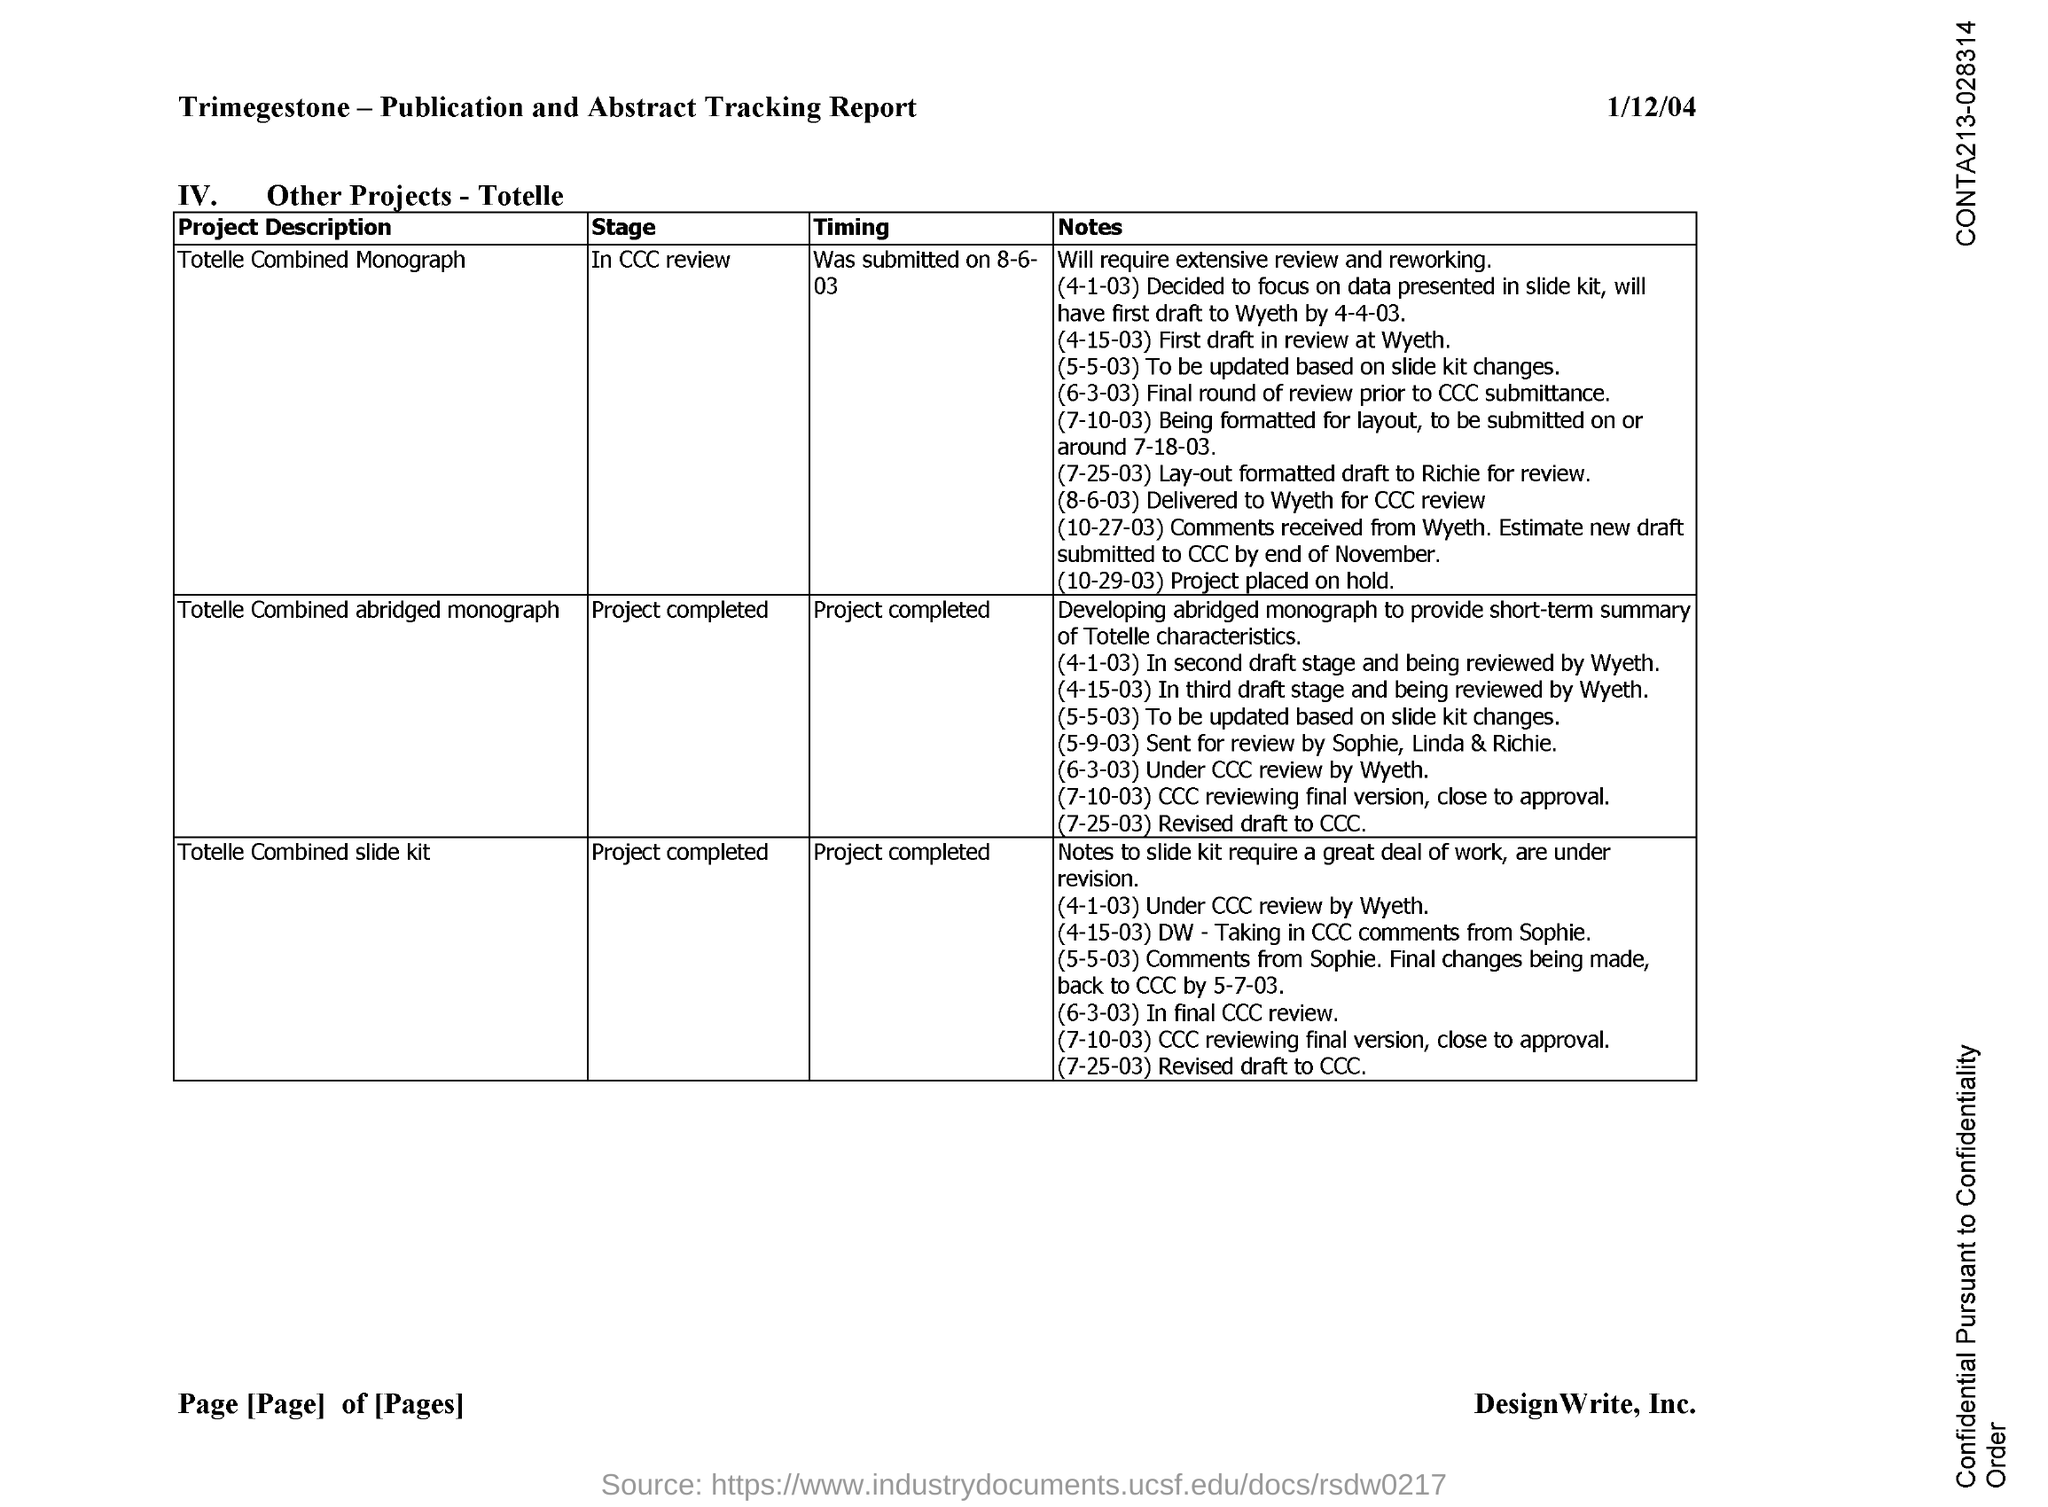Give some essential details in this illustration. The date mentioned in the document is January 12, 2004. 